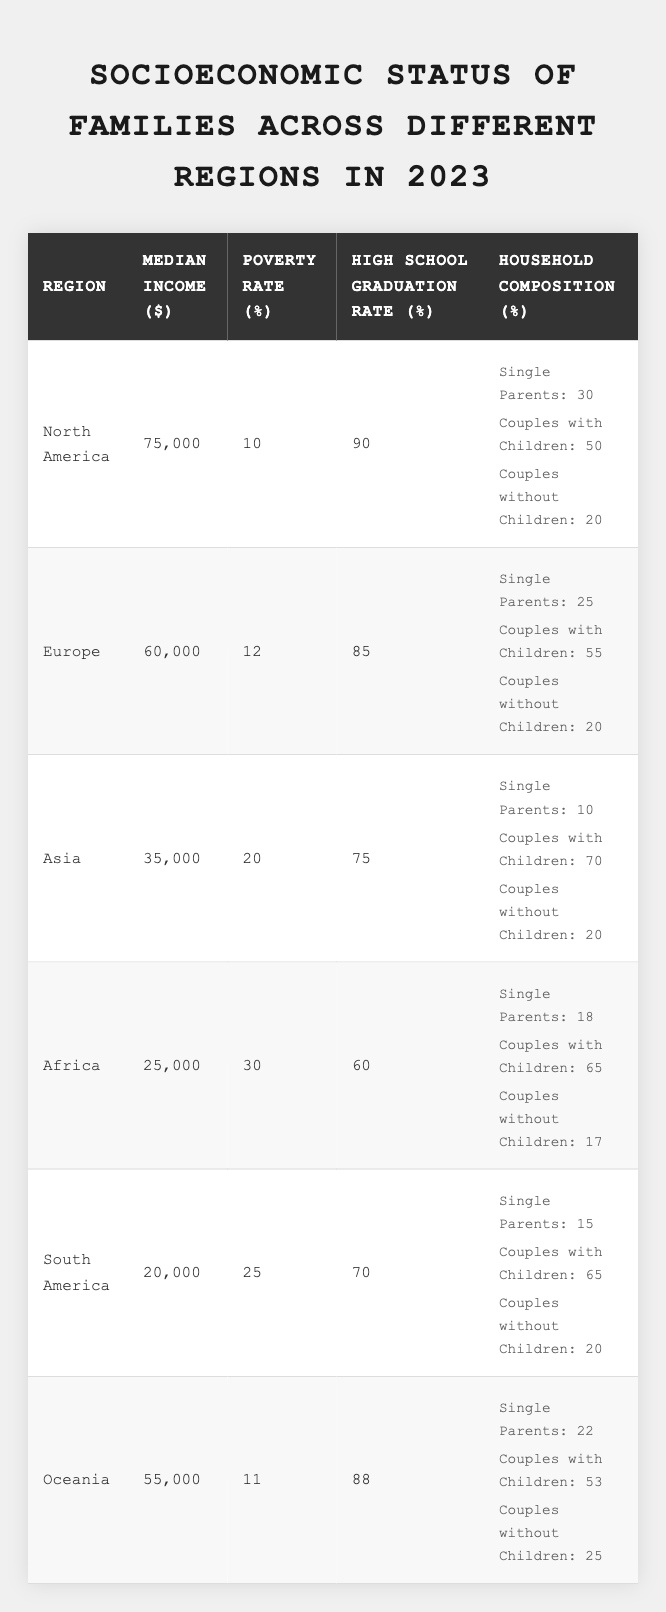What is the median income in North America? The table shows that the median income for North America is listed directly under the Median Income column as 75,000.
Answer: 75,000 What is the poverty rate in Africa? Referring to the Poverty Rate column for Africa in the table, it is listed as 30.
Answer: 30 Which region has the highest high school graduation rate? By comparing the High School Graduation Rate for all regions, North America has the highest rate of 90.
Answer: North America What is the percentage of single parents in Oceania? According to the Household Composition for Oceania in the table, it is noted as 22 under Single Parents.
Answer: 22 Which region has a lower median income: South America or Africa? South America has a median income of 20,000, while Africa has 25,000. Since 20,000 is less than 25,000, South America has a lower median income.
Answer: South America What is the difference in poverty rates between North America and Europe? The poverty rate for North America is 10, and for Europe, it is 12. The difference is calculated as 12 - 10 = 2.
Answer: 2 What is the average high school graduation rate across all regions? To find the average, sum the graduation rates: (90 + 85 + 75 + 60 + 70 + 88) = 468, then divide by the number of regions (6): 468 / 6 = 78.
Answer: 78 Which region has the lowest percentage of single parents? Looking at the Single Parents percentages across regions, Asia has the lowest at 10.
Answer: Asia Is the high school graduation rate in Europe greater than that in Asia? The data shows Europe has a high school graduation rate of 85 while Asia has 75, which indicates that Europe’s rate is indeed greater.
Answer: Yes How many regions have a poverty rate above 20%? By examining the Poverty Rate for each region, Asia (20), Africa (30), and South America (25) are above 20%, totaling 3 regions.
Answer: 3 Which household composition type has the highest percentage in Africa? In Africa, the highest percentage is Couples with Children at 65, which is greater than Single Parents at 18 or Couples without Children at 17.
Answer: Couples with Children What is the percentage increase in median income from South America to North America? Calculate the increase as (75,000 - 20,000) = 55,000. The percentage increase is (55,000 / 20,000) * 100 = 275%.
Answer: 275% 